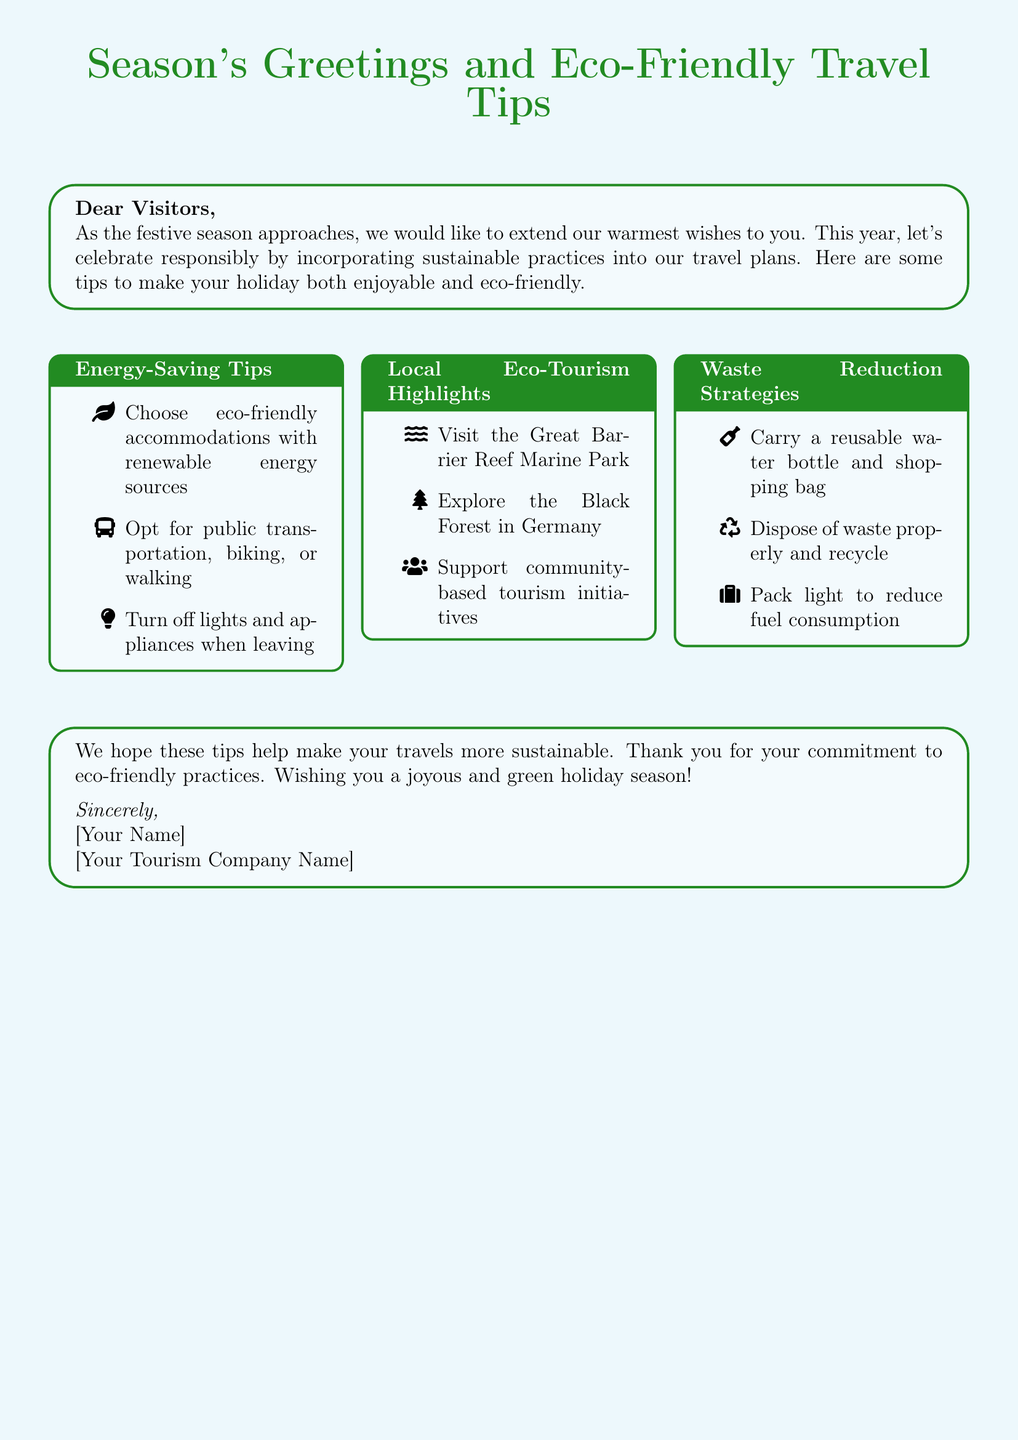What is the title of the card? The title appears prominently at the top of the card and is "Season's Greetings and Eco-Friendly Travel Tips."
Answer: Season's Greetings and Eco-Friendly Travel Tips Who is the card addressed to? The greeting card is addressed to visitors in the opening line.
Answer: Visitors What color is used for the card's background? The background color of the card is specified in the document as sky blue.
Answer: Sky blue Name one energy-saving tip provided in the card. An example of an energy-saving tip listed in the card is "Choose eco-friendly accommodations with renewable energy sources."
Answer: Choose eco-friendly accommodations with renewable energy sources How many local eco-tourism highlights are mentioned? Three local eco-tourism highlights are listed in the respective section of the card.
Answer: Three What is one waste reduction strategy suggested? One waste reduction strategy mentioned is "Carry a reusable water bottle and shopping bag."
Answer: Carry a reusable water bottle and shopping bag What is the tone of the closing message? The closing message expresses gratitude and wishes joyfulness, indicating a positive and warm tone.
Answer: Joyous and green holiday season What is the overall purpose of this card? The card aims to extend seasonal greetings while promoting sustainable travel practices among visitors.
Answer: Promote sustainable travel practices 